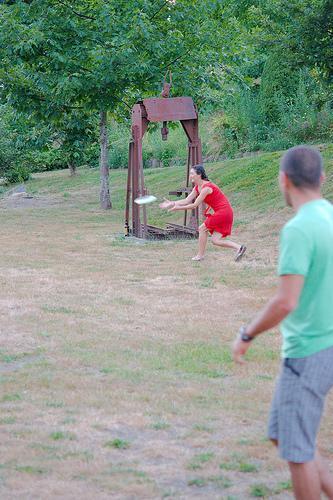How many people are playing?
Give a very brief answer. 2. 